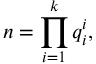<formula> <loc_0><loc_0><loc_500><loc_500>n = \prod _ { i = 1 } ^ { k } q _ { i } ^ { i } ,</formula> 